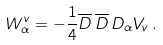<formula> <loc_0><loc_0><loc_500><loc_500>W _ { \alpha } ^ { v } = - \frac { 1 } { 4 } \overline { D } \, \overline { D } \, D _ { \alpha } { V _ { v } } \, .</formula> 